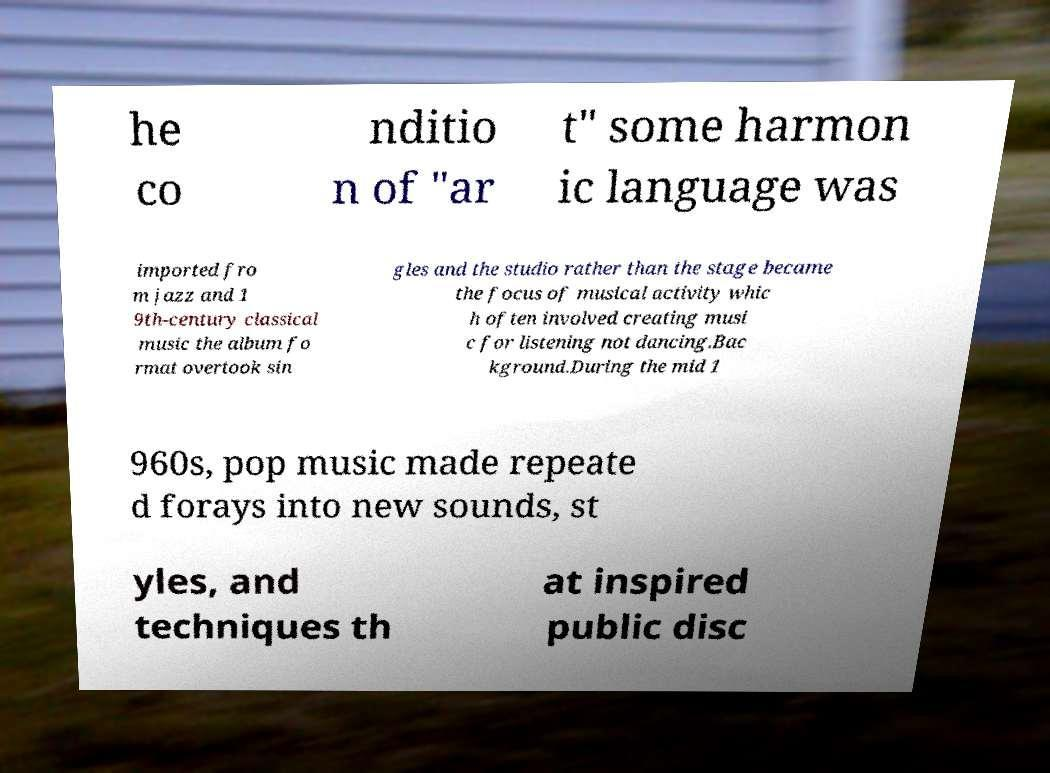Can you accurately transcribe the text from the provided image for me? he co nditio n of "ar t" some harmon ic language was imported fro m jazz and 1 9th-century classical music the album fo rmat overtook sin gles and the studio rather than the stage became the focus of musical activity whic h often involved creating musi c for listening not dancing.Bac kground.During the mid 1 960s, pop music made repeate d forays into new sounds, st yles, and techniques th at inspired public disc 